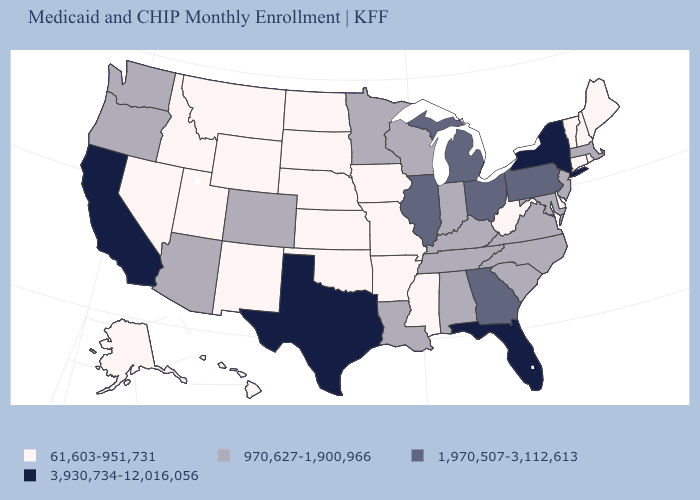Does Delaware have the lowest value in the USA?
Keep it brief. Yes. Among the states that border Michigan , which have the highest value?
Give a very brief answer. Ohio. What is the value of New Hampshire?
Quick response, please. 61,603-951,731. Name the states that have a value in the range 61,603-951,731?
Be succinct. Alaska, Arkansas, Connecticut, Delaware, Hawaii, Idaho, Iowa, Kansas, Maine, Mississippi, Missouri, Montana, Nebraska, Nevada, New Hampshire, New Mexico, North Dakota, Oklahoma, Rhode Island, South Dakota, Utah, Vermont, West Virginia, Wyoming. Name the states that have a value in the range 1,970,507-3,112,613?
Answer briefly. Georgia, Illinois, Michigan, Ohio, Pennsylvania. Name the states that have a value in the range 3,930,734-12,016,056?
Be succinct. California, Florida, New York, Texas. What is the value of Massachusetts?
Short answer required. 970,627-1,900,966. What is the value of West Virginia?
Keep it brief. 61,603-951,731. Is the legend a continuous bar?
Short answer required. No. Does Kansas have the lowest value in the MidWest?
Give a very brief answer. Yes. Name the states that have a value in the range 1,970,507-3,112,613?
Give a very brief answer. Georgia, Illinois, Michigan, Ohio, Pennsylvania. What is the lowest value in the West?
Answer briefly. 61,603-951,731. Name the states that have a value in the range 61,603-951,731?
Quick response, please. Alaska, Arkansas, Connecticut, Delaware, Hawaii, Idaho, Iowa, Kansas, Maine, Mississippi, Missouri, Montana, Nebraska, Nevada, New Hampshire, New Mexico, North Dakota, Oklahoma, Rhode Island, South Dakota, Utah, Vermont, West Virginia, Wyoming. Name the states that have a value in the range 3,930,734-12,016,056?
Short answer required. California, Florida, New York, Texas. Does the first symbol in the legend represent the smallest category?
Concise answer only. Yes. 